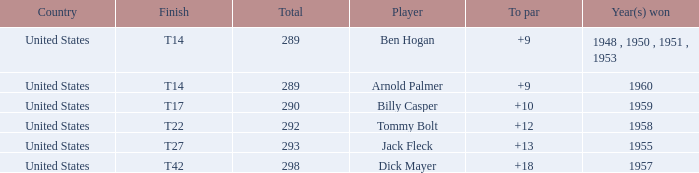What is Player, when Year(s) Won is 1955? Jack Fleck. 